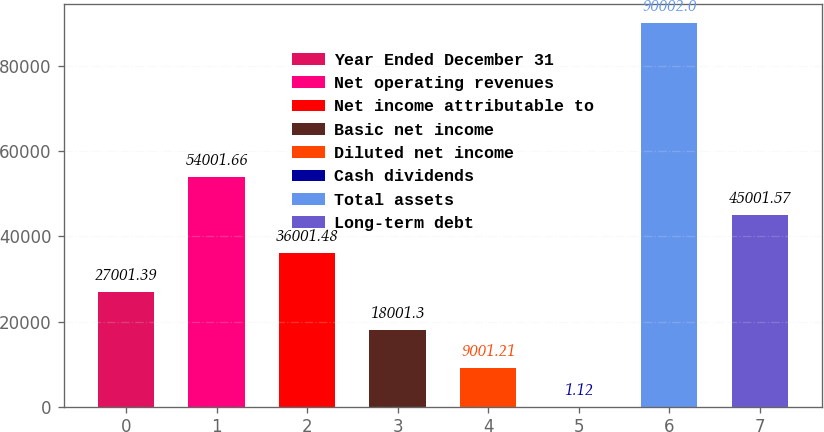Convert chart to OTSL. <chart><loc_0><loc_0><loc_500><loc_500><bar_chart><fcel>Year Ended December 31<fcel>Net operating revenues<fcel>Net income attributable to<fcel>Basic net income<fcel>Diluted net income<fcel>Cash dividends<fcel>Total assets<fcel>Long-term debt<nl><fcel>27001.4<fcel>54001.7<fcel>36001.5<fcel>18001.3<fcel>9001.21<fcel>1.12<fcel>90002<fcel>45001.6<nl></chart> 